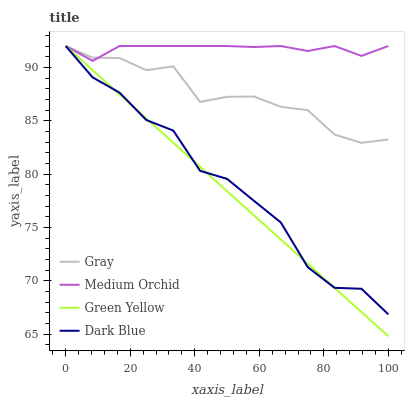Does Green Yellow have the minimum area under the curve?
Answer yes or no. Yes. Does Medium Orchid have the maximum area under the curve?
Answer yes or no. Yes. Does Medium Orchid have the minimum area under the curve?
Answer yes or no. No. Does Green Yellow have the maximum area under the curve?
Answer yes or no. No. Is Green Yellow the smoothest?
Answer yes or no. Yes. Is Dark Blue the roughest?
Answer yes or no. Yes. Is Medium Orchid the smoothest?
Answer yes or no. No. Is Medium Orchid the roughest?
Answer yes or no. No. Does Medium Orchid have the lowest value?
Answer yes or no. No. 